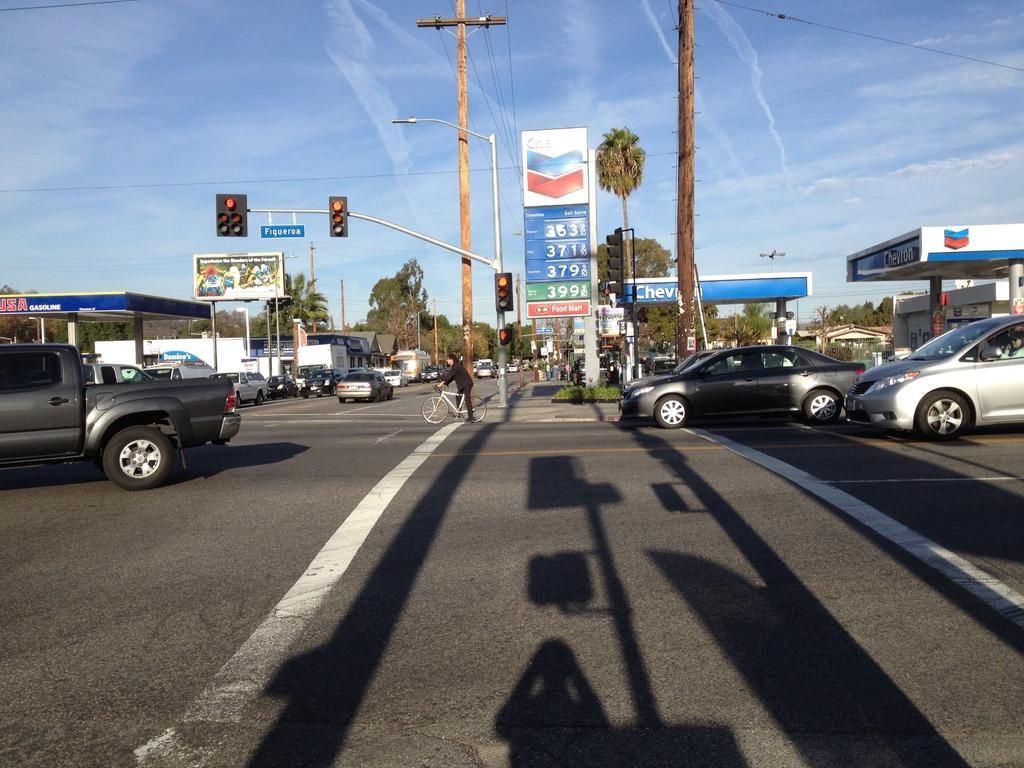In one or two sentences, can you explain what this image depicts? In this image I can see vehicles and a bicycle on the road. Here I can see a person is sitting on the bicycle, traffic lights, poles which has wires, streetlights and petrol pumps. In the background I can see trees, houses and the sky. 